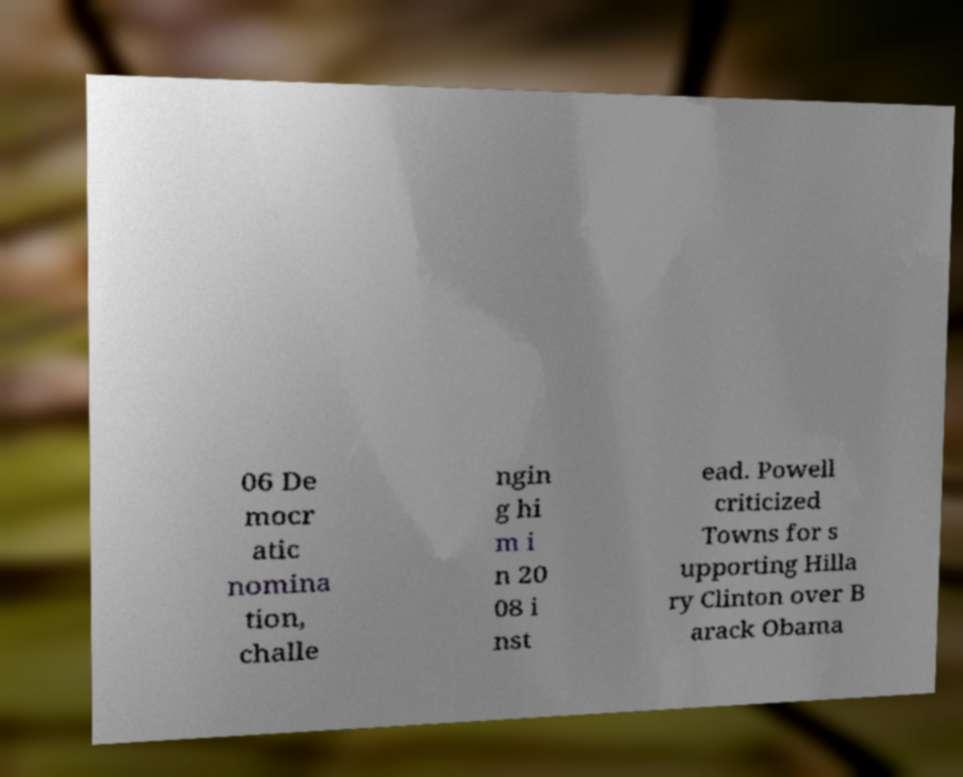For documentation purposes, I need the text within this image transcribed. Could you provide that? 06 De mocr atic nomina tion, challe ngin g hi m i n 20 08 i nst ead. Powell criticized Towns for s upporting Hilla ry Clinton over B arack Obama 